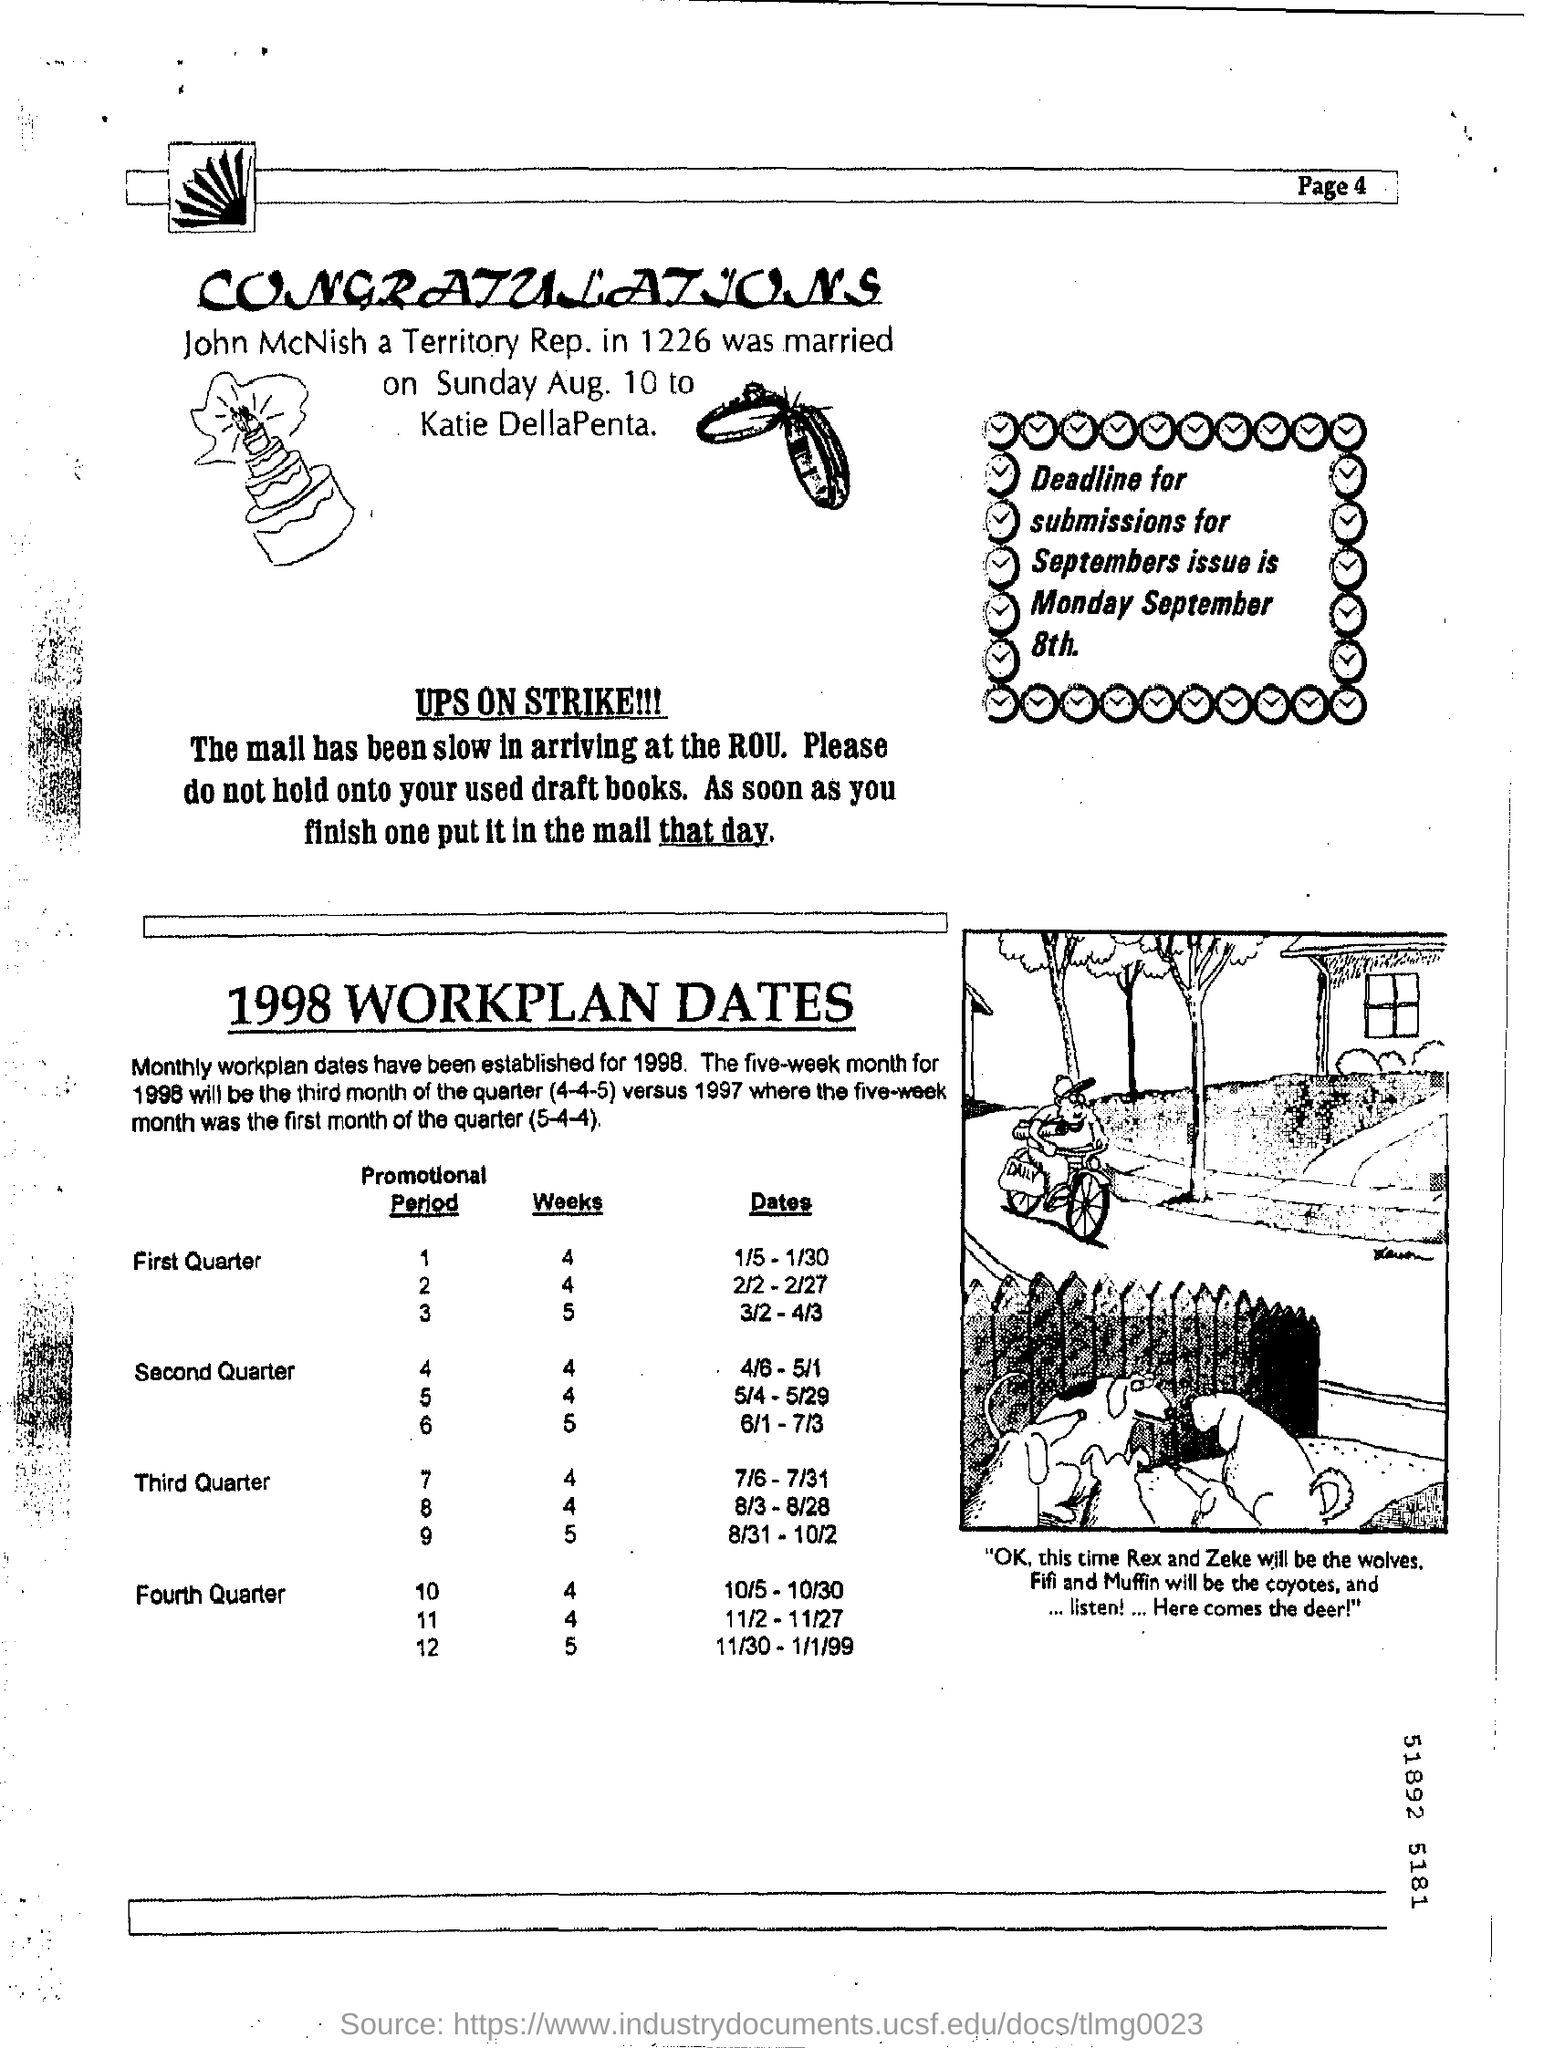What is the deadline for submissions for Septembers issue ?
Offer a terse response. Monday September 8th. Who is John McNish?
Offer a very short reply. A Territory Rep. To whom , John McNish is married to?
Your response must be concise. Katie DellaPenta. What is the page no mentioned in this document?
Your answer should be very brief. 4. 